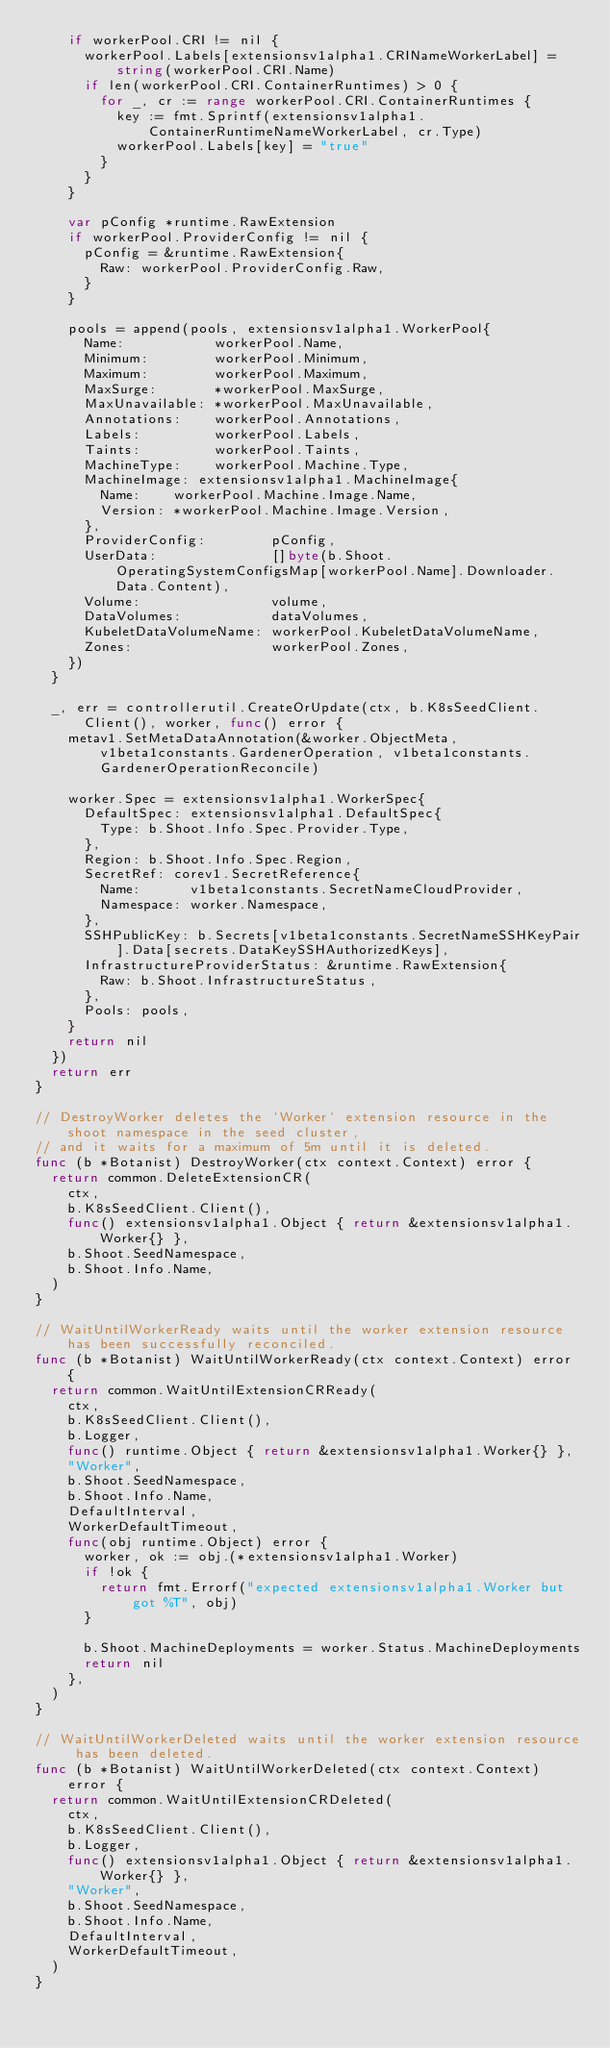Convert code to text. <code><loc_0><loc_0><loc_500><loc_500><_Go_>		if workerPool.CRI != nil {
			workerPool.Labels[extensionsv1alpha1.CRINameWorkerLabel] = string(workerPool.CRI.Name)
			if len(workerPool.CRI.ContainerRuntimes) > 0 {
				for _, cr := range workerPool.CRI.ContainerRuntimes {
					key := fmt.Sprintf(extensionsv1alpha1.ContainerRuntimeNameWorkerLabel, cr.Type)
					workerPool.Labels[key] = "true"
				}
			}
		}

		var pConfig *runtime.RawExtension
		if workerPool.ProviderConfig != nil {
			pConfig = &runtime.RawExtension{
				Raw: workerPool.ProviderConfig.Raw,
			}
		}

		pools = append(pools, extensionsv1alpha1.WorkerPool{
			Name:           workerPool.Name,
			Minimum:        workerPool.Minimum,
			Maximum:        workerPool.Maximum,
			MaxSurge:       *workerPool.MaxSurge,
			MaxUnavailable: *workerPool.MaxUnavailable,
			Annotations:    workerPool.Annotations,
			Labels:         workerPool.Labels,
			Taints:         workerPool.Taints,
			MachineType:    workerPool.Machine.Type,
			MachineImage: extensionsv1alpha1.MachineImage{
				Name:    workerPool.Machine.Image.Name,
				Version: *workerPool.Machine.Image.Version,
			},
			ProviderConfig:        pConfig,
			UserData:              []byte(b.Shoot.OperatingSystemConfigsMap[workerPool.Name].Downloader.Data.Content),
			Volume:                volume,
			DataVolumes:           dataVolumes,
			KubeletDataVolumeName: workerPool.KubeletDataVolumeName,
			Zones:                 workerPool.Zones,
		})
	}

	_, err = controllerutil.CreateOrUpdate(ctx, b.K8sSeedClient.Client(), worker, func() error {
		metav1.SetMetaDataAnnotation(&worker.ObjectMeta, v1beta1constants.GardenerOperation, v1beta1constants.GardenerOperationReconcile)

		worker.Spec = extensionsv1alpha1.WorkerSpec{
			DefaultSpec: extensionsv1alpha1.DefaultSpec{
				Type: b.Shoot.Info.Spec.Provider.Type,
			},
			Region: b.Shoot.Info.Spec.Region,
			SecretRef: corev1.SecretReference{
				Name:      v1beta1constants.SecretNameCloudProvider,
				Namespace: worker.Namespace,
			},
			SSHPublicKey: b.Secrets[v1beta1constants.SecretNameSSHKeyPair].Data[secrets.DataKeySSHAuthorizedKeys],
			InfrastructureProviderStatus: &runtime.RawExtension{
				Raw: b.Shoot.InfrastructureStatus,
			},
			Pools: pools,
		}
		return nil
	})
	return err
}

// DestroyWorker deletes the `Worker` extension resource in the shoot namespace in the seed cluster,
// and it waits for a maximum of 5m until it is deleted.
func (b *Botanist) DestroyWorker(ctx context.Context) error {
	return common.DeleteExtensionCR(
		ctx,
		b.K8sSeedClient.Client(),
		func() extensionsv1alpha1.Object { return &extensionsv1alpha1.Worker{} },
		b.Shoot.SeedNamespace,
		b.Shoot.Info.Name,
	)
}

// WaitUntilWorkerReady waits until the worker extension resource has been successfully reconciled.
func (b *Botanist) WaitUntilWorkerReady(ctx context.Context) error {
	return common.WaitUntilExtensionCRReady(
		ctx,
		b.K8sSeedClient.Client(),
		b.Logger,
		func() runtime.Object { return &extensionsv1alpha1.Worker{} },
		"Worker",
		b.Shoot.SeedNamespace,
		b.Shoot.Info.Name,
		DefaultInterval,
		WorkerDefaultTimeout,
		func(obj runtime.Object) error {
			worker, ok := obj.(*extensionsv1alpha1.Worker)
			if !ok {
				return fmt.Errorf("expected extensionsv1alpha1.Worker but got %T", obj)
			}

			b.Shoot.MachineDeployments = worker.Status.MachineDeployments
			return nil
		},
	)
}

// WaitUntilWorkerDeleted waits until the worker extension resource has been deleted.
func (b *Botanist) WaitUntilWorkerDeleted(ctx context.Context) error {
	return common.WaitUntilExtensionCRDeleted(
		ctx,
		b.K8sSeedClient.Client(),
		b.Logger,
		func() extensionsv1alpha1.Object { return &extensionsv1alpha1.Worker{} },
		"Worker",
		b.Shoot.SeedNamespace,
		b.Shoot.Info.Name,
		DefaultInterval,
		WorkerDefaultTimeout,
	)
}
</code> 